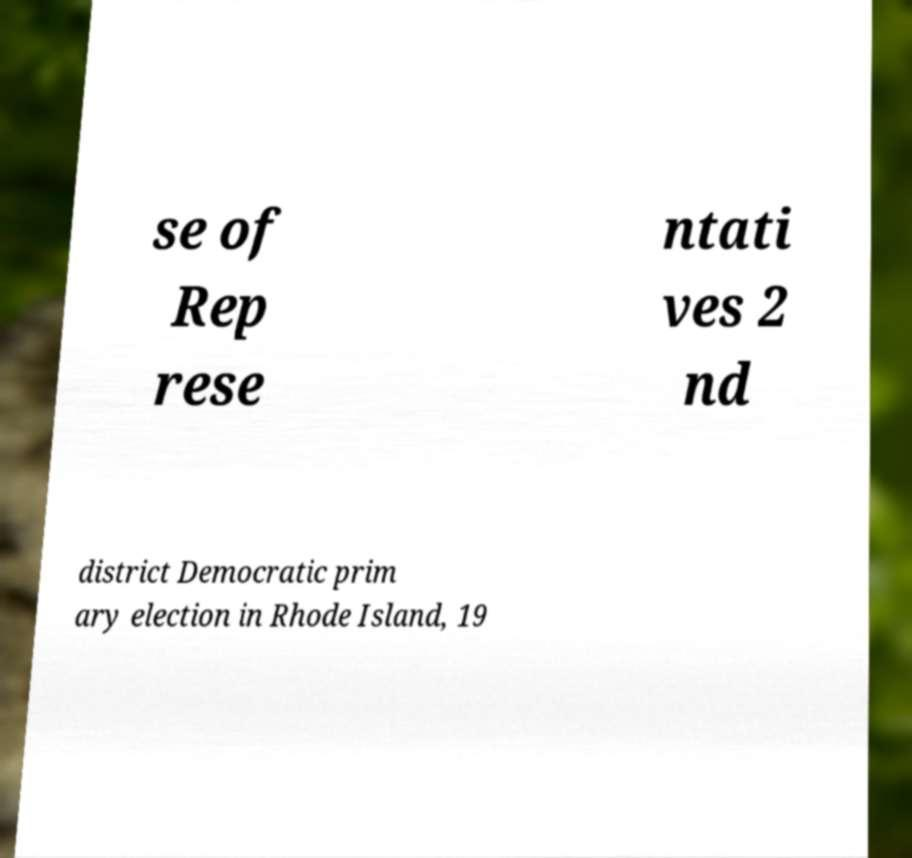There's text embedded in this image that I need extracted. Can you transcribe it verbatim? se of Rep rese ntati ves 2 nd district Democratic prim ary election in Rhode Island, 19 